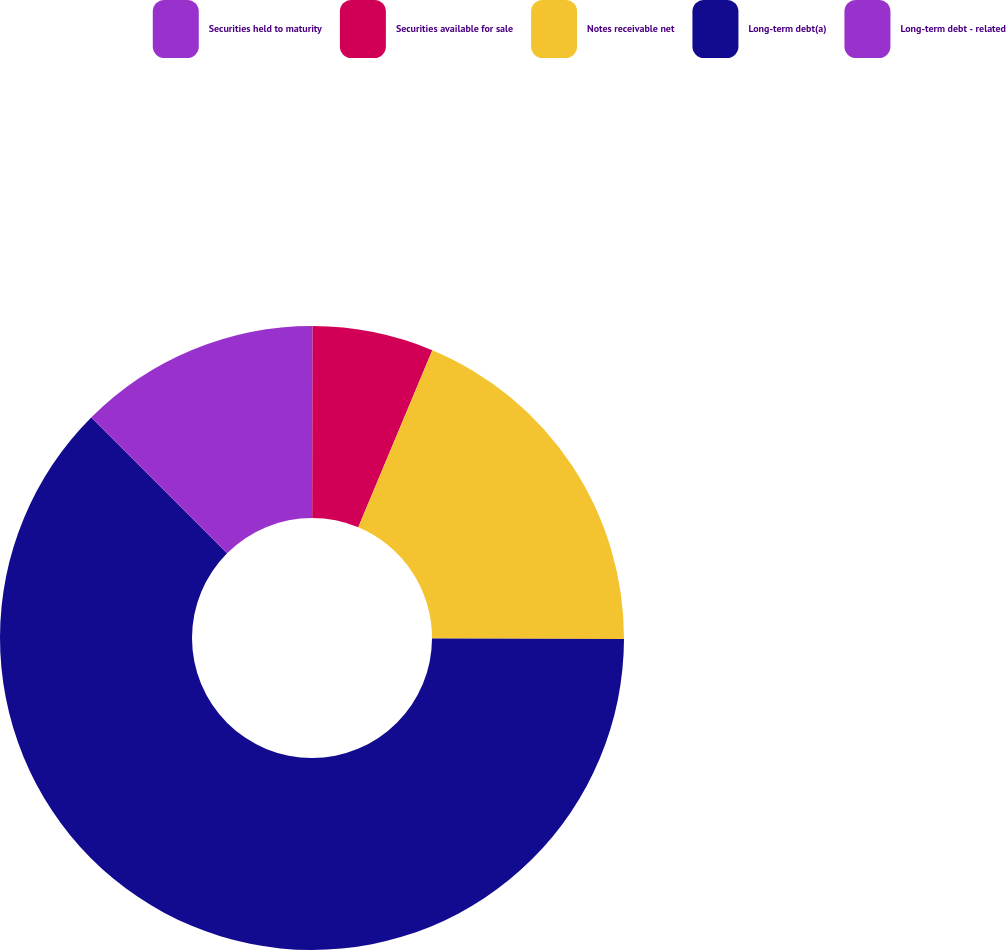<chart> <loc_0><loc_0><loc_500><loc_500><pie_chart><fcel>Securities held to maturity<fcel>Securities available for sale<fcel>Notes receivable net<fcel>Long-term debt(a)<fcel>Long-term debt - related<nl><fcel>0.03%<fcel>6.27%<fcel>18.75%<fcel>62.43%<fcel>12.51%<nl></chart> 